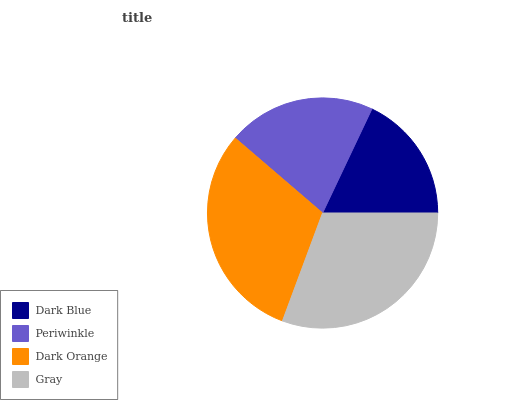Is Dark Blue the minimum?
Answer yes or no. Yes. Is Gray the maximum?
Answer yes or no. Yes. Is Periwinkle the minimum?
Answer yes or no. No. Is Periwinkle the maximum?
Answer yes or no. No. Is Periwinkle greater than Dark Blue?
Answer yes or no. Yes. Is Dark Blue less than Periwinkle?
Answer yes or no. Yes. Is Dark Blue greater than Periwinkle?
Answer yes or no. No. Is Periwinkle less than Dark Blue?
Answer yes or no. No. Is Dark Orange the high median?
Answer yes or no. Yes. Is Periwinkle the low median?
Answer yes or no. Yes. Is Dark Blue the high median?
Answer yes or no. No. Is Dark Orange the low median?
Answer yes or no. No. 